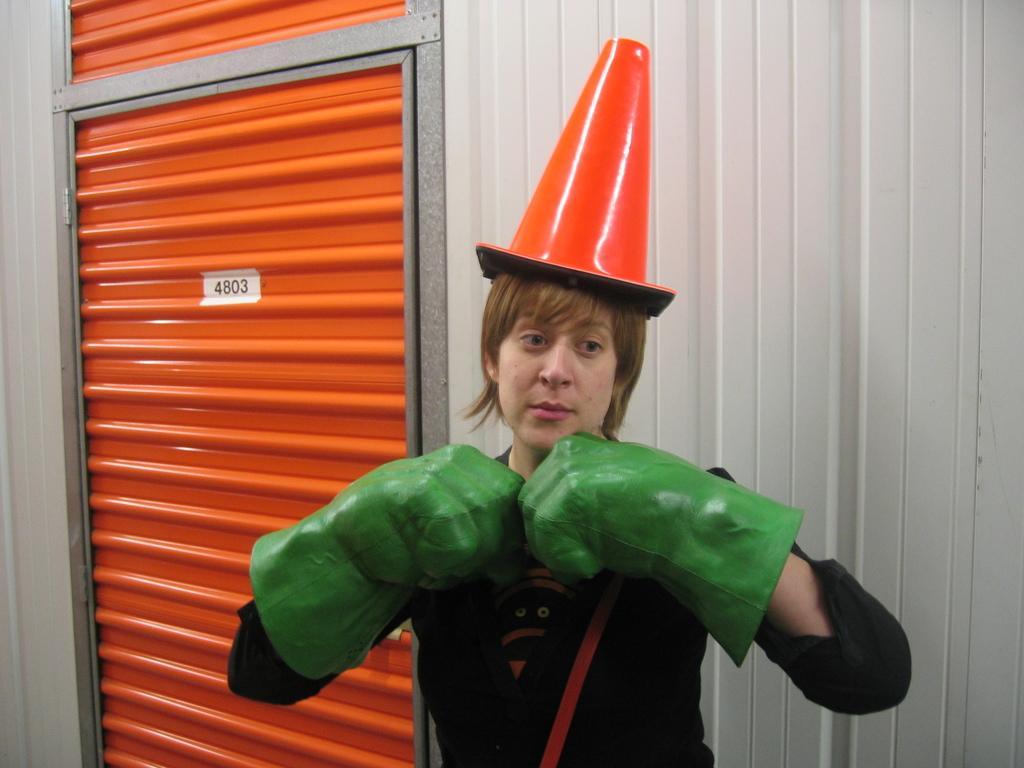Please provide a concise description of this image. In this picture, we can see a lady wearing hat, and hand gloves, we can see the wall with door and some numbers on it. 